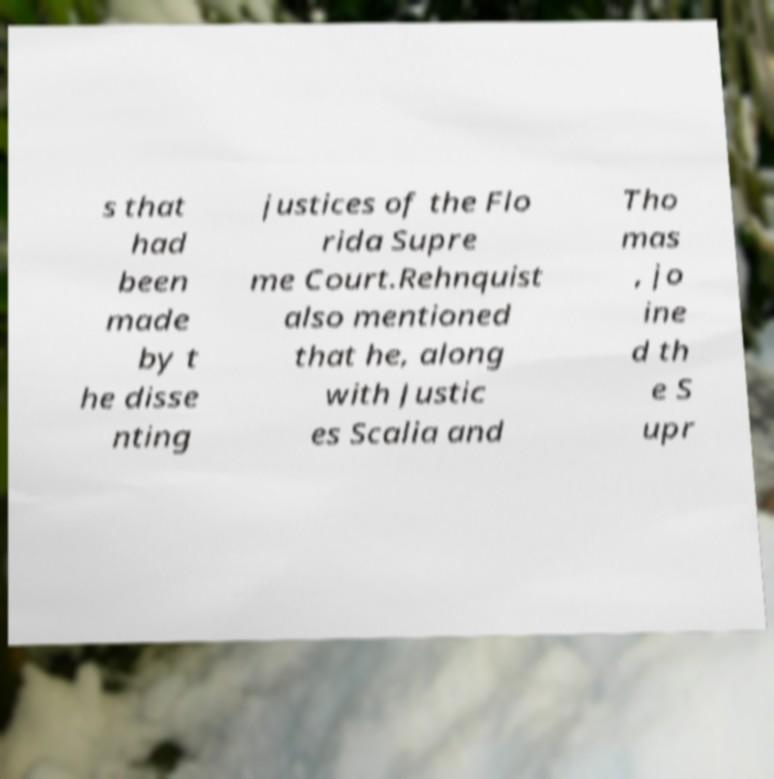I need the written content from this picture converted into text. Can you do that? s that had been made by t he disse nting justices of the Flo rida Supre me Court.Rehnquist also mentioned that he, along with Justic es Scalia and Tho mas , jo ine d th e S upr 